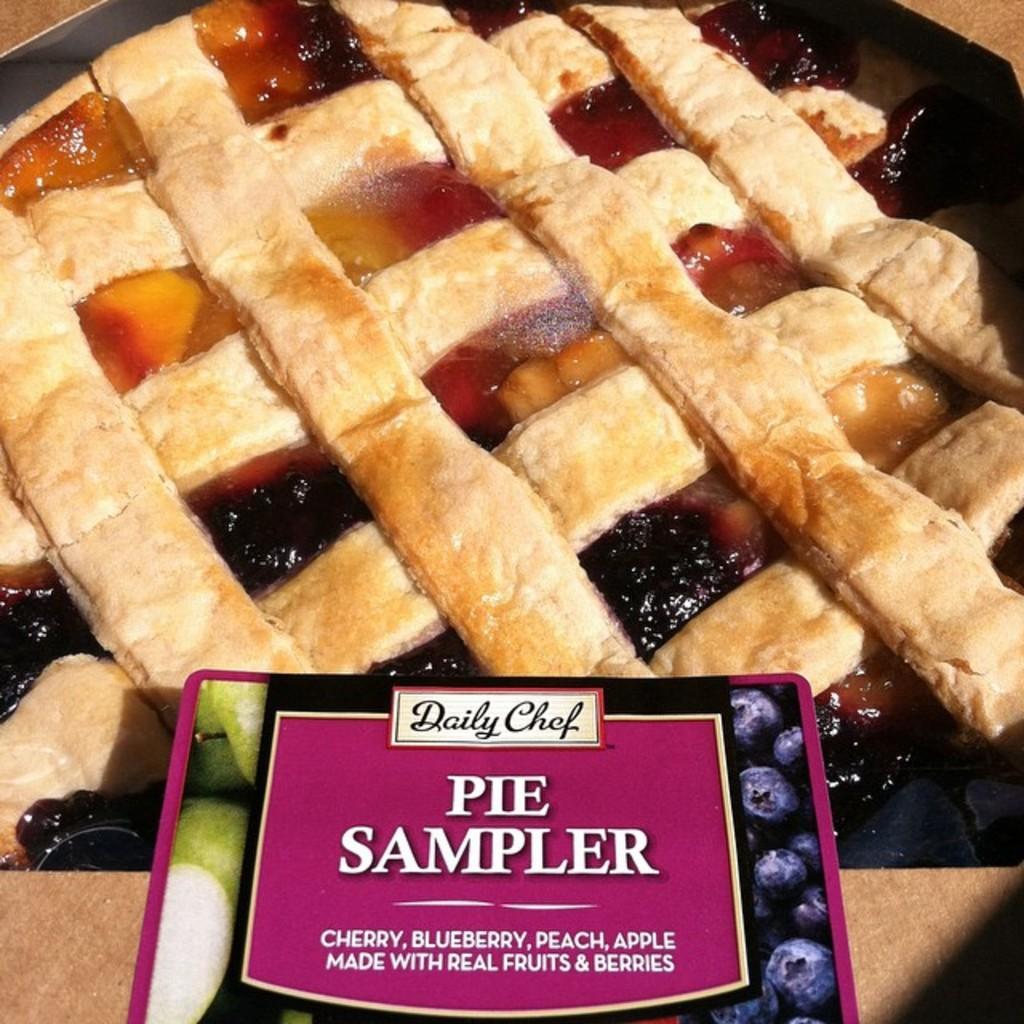Describe this image in one or two sentences. In this image, we can see some food in the tray and there is a sticker. 